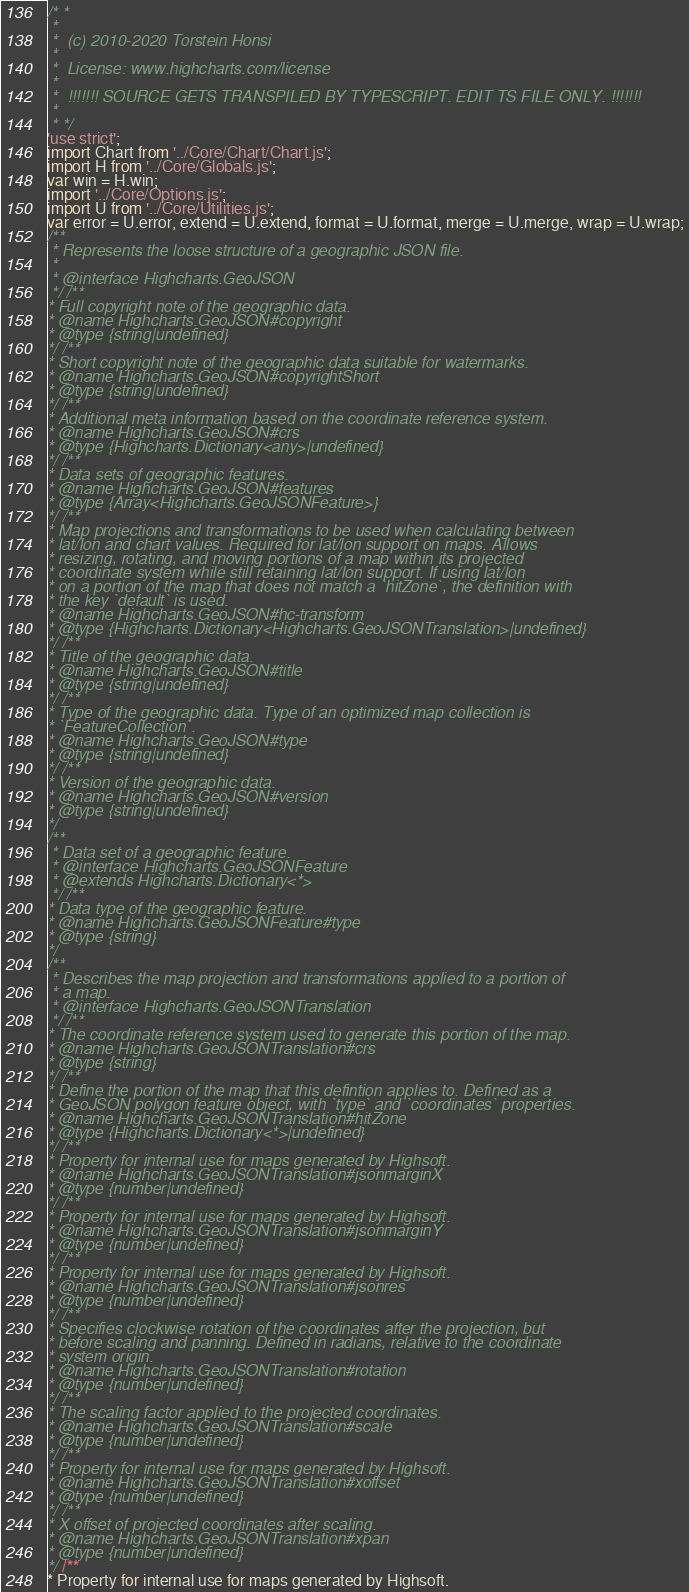Convert code to text. <code><loc_0><loc_0><loc_500><loc_500><_JavaScript_>/* *
 *
 *  (c) 2010-2020 Torstein Honsi
 *
 *  License: www.highcharts.com/license
 *
 *  !!!!!!! SOURCE GETS TRANSPILED BY TYPESCRIPT. EDIT TS FILE ONLY. !!!!!!!
 *
 * */
'use strict';
import Chart from '../Core/Chart/Chart.js';
import H from '../Core/Globals.js';
var win = H.win;
import '../Core/Options.js';
import U from '../Core/Utilities.js';
var error = U.error, extend = U.extend, format = U.format, merge = U.merge, wrap = U.wrap;
/**
 * Represents the loose structure of a geographic JSON file.
 *
 * @interface Highcharts.GeoJSON
 */ /**
* Full copyright note of the geographic data.
* @name Highcharts.GeoJSON#copyright
* @type {string|undefined}
*/ /**
* Short copyright note of the geographic data suitable for watermarks.
* @name Highcharts.GeoJSON#copyrightShort
* @type {string|undefined}
*/ /**
* Additional meta information based on the coordinate reference system.
* @name Highcharts.GeoJSON#crs
* @type {Highcharts.Dictionary<any>|undefined}
*/ /**
* Data sets of geographic features.
* @name Highcharts.GeoJSON#features
* @type {Array<Highcharts.GeoJSONFeature>}
*/ /**
* Map projections and transformations to be used when calculating between
* lat/lon and chart values. Required for lat/lon support on maps. Allows
* resizing, rotating, and moving portions of a map within its projected
* coordinate system while still retaining lat/lon support. If using lat/lon
* on a portion of the map that does not match a `hitZone`, the definition with
* the key `default` is used.
* @name Highcharts.GeoJSON#hc-transform
* @type {Highcharts.Dictionary<Highcharts.GeoJSONTranslation>|undefined}
*/ /**
* Title of the geographic data.
* @name Highcharts.GeoJSON#title
* @type {string|undefined}
*/ /**
* Type of the geographic data. Type of an optimized map collection is
* `FeatureCollection`.
* @name Highcharts.GeoJSON#type
* @type {string|undefined}
*/ /**
* Version of the geographic data.
* @name Highcharts.GeoJSON#version
* @type {string|undefined}
*/
/**
 * Data set of a geographic feature.
 * @interface Highcharts.GeoJSONFeature
 * @extends Highcharts.Dictionary<*>
 */ /**
* Data type of the geographic feature.
* @name Highcharts.GeoJSONFeature#type
* @type {string}
*/
/**
 * Describes the map projection and transformations applied to a portion of
 * a map.
 * @interface Highcharts.GeoJSONTranslation
 */ /**
* The coordinate reference system used to generate this portion of the map.
* @name Highcharts.GeoJSONTranslation#crs
* @type {string}
*/ /**
* Define the portion of the map that this defintion applies to. Defined as a
* GeoJSON polygon feature object, with `type` and `coordinates` properties.
* @name Highcharts.GeoJSONTranslation#hitZone
* @type {Highcharts.Dictionary<*>|undefined}
*/ /**
* Property for internal use for maps generated by Highsoft.
* @name Highcharts.GeoJSONTranslation#jsonmarginX
* @type {number|undefined}
*/ /**
* Property for internal use for maps generated by Highsoft.
* @name Highcharts.GeoJSONTranslation#jsonmarginY
* @type {number|undefined}
*/ /**
* Property for internal use for maps generated by Highsoft.
* @name Highcharts.GeoJSONTranslation#jsonres
* @type {number|undefined}
*/ /**
* Specifies clockwise rotation of the coordinates after the projection, but
* before scaling and panning. Defined in radians, relative to the coordinate
* system origin.
* @name Highcharts.GeoJSONTranslation#rotation
* @type {number|undefined}
*/ /**
* The scaling factor applied to the projected coordinates.
* @name Highcharts.GeoJSONTranslation#scale
* @type {number|undefined}
*/ /**
* Property for internal use for maps generated by Highsoft.
* @name Highcharts.GeoJSONTranslation#xoffset
* @type {number|undefined}
*/ /**
* X offset of projected coordinates after scaling.
* @name Highcharts.GeoJSONTranslation#xpan
* @type {number|undefined}
*/ /**
* Property for internal use for maps generated by Highsoft.</code> 